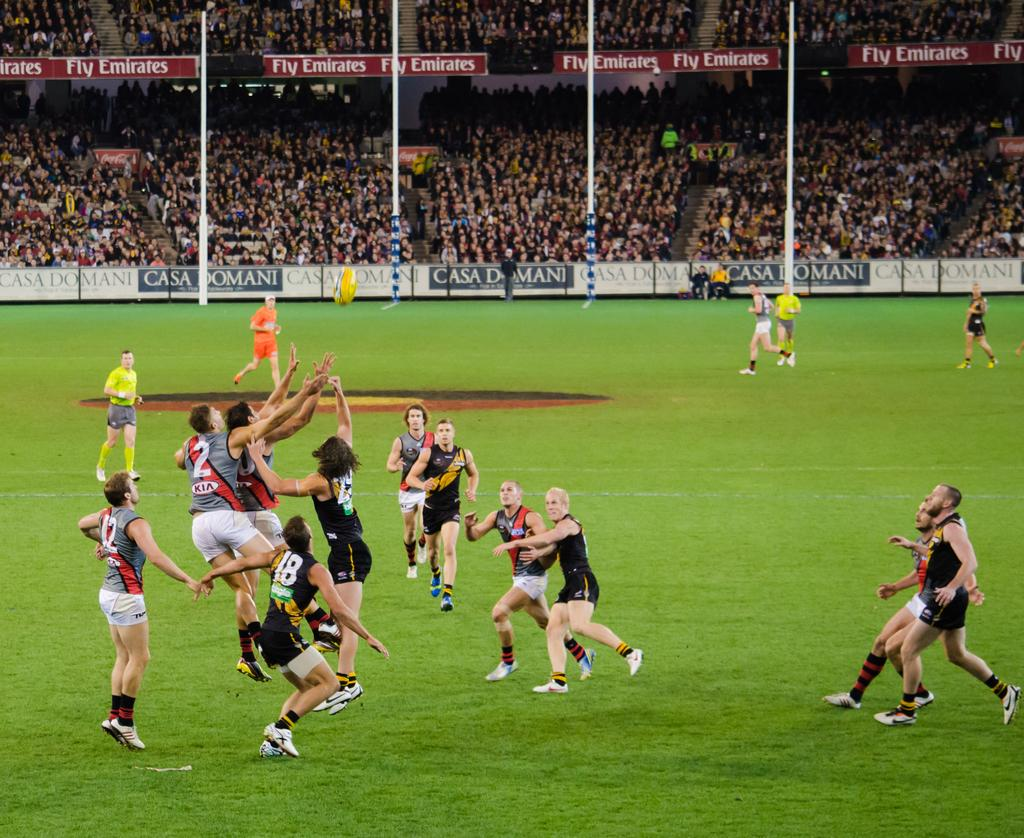<image>
Summarize the visual content of the image. A game with a lot of players with advertisements that say casa domani. 